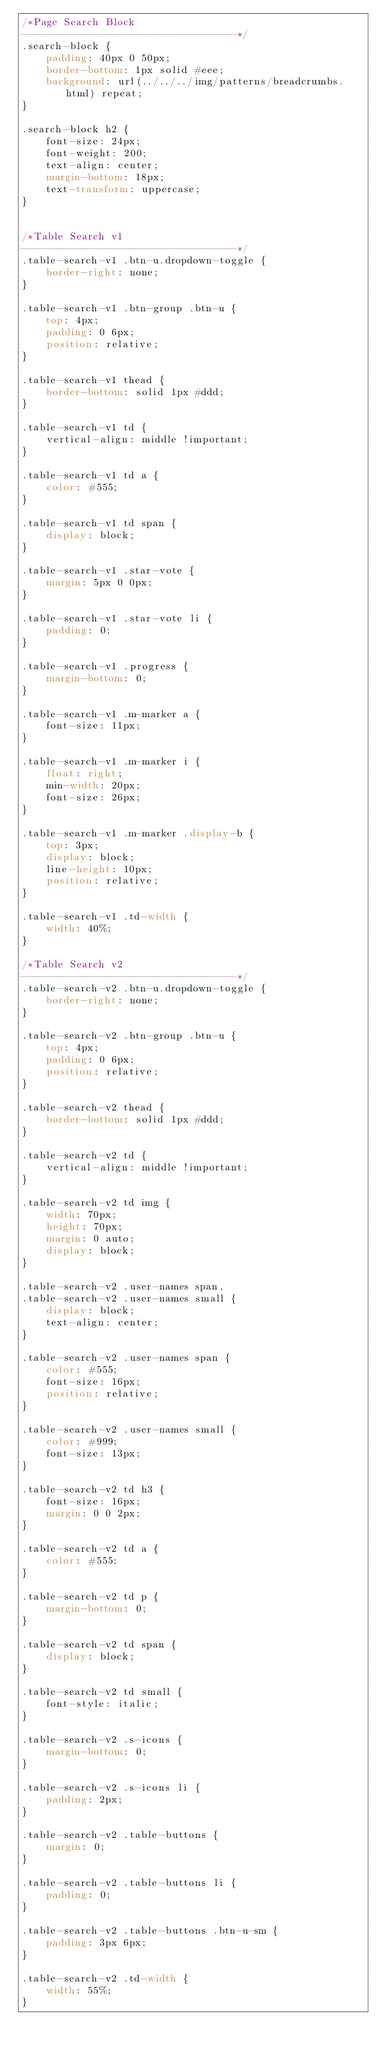<code> <loc_0><loc_0><loc_500><loc_500><_CSS_>/*Page Search Block
------------------------------------*/
.search-block {
	padding: 40px 0 50px;
	border-bottom: 1px solid #eee;
	background: url(../../../img/patterns/breadcrumbs.html) repeat;
}

.search-block h2 {
	font-size: 24px;
	font-weight: 200;
	text-align: center;
	margin-bottom: 18px;
	text-transform: uppercase;
}


/*Table Search v1
------------------------------------*/
.table-search-v1 .btn-u.dropdown-toggle {
	border-right: none;
}

.table-search-v1 .btn-group .btn-u {
	top: 4px;
	padding: 0 6px;
	position: relative;
}

.table-search-v1 thead {
	border-bottom: solid 1px #ddd;
}

.table-search-v1 td {
	vertical-align: middle !important;
}

.table-search-v1 td a {
	color: #555;
}

.table-search-v1 td span {
	display: block;
}

.table-search-v1 .star-vote {
	margin: 5px 0 0px;
}

.table-search-v1 .star-vote li {
	padding: 0;
}

.table-search-v1 .progress {
	margin-bottom: 0;
}

.table-search-v1 .m-marker a {
	font-size: 11px;
}

.table-search-v1 .m-marker i {
	float: right;
	min-width: 20px;
	font-size: 26px;
}

.table-search-v1 .m-marker .display-b {
	top: 3px;
	display: block;
	line-height: 10px;
	position: relative;
}

.table-search-v1 .td-width {
	width: 40%;
}

/*Table Search v2
------------------------------------*/
.table-search-v2 .btn-u.dropdown-toggle {
	border-right: none;
}

.table-search-v2 .btn-group .btn-u {
	top: 4px;
	padding: 0 6px;
	position: relative;
}

.table-search-v2 thead {
	border-bottom: solid 1px #ddd;
}

.table-search-v2 td {
	vertical-align: middle !important;
}

.table-search-v2 td img {
	width: 70px;
	height: 70px;
	margin: 0 auto;
	display: block;
}

.table-search-v2 .user-names span,
.table-search-v2 .user-names small {
	display: block;
	text-align: center;
}

.table-search-v2 .user-names span {
	color: #555;
	font-size: 16px;
	position: relative;
}

.table-search-v2 .user-names small {
	color: #999;
	font-size: 13px;
}

.table-search-v2 td h3 {
	font-size: 16px;
	margin: 0 0 2px;
}

.table-search-v2 td a {
	color: #555;
}

.table-search-v2 td p {
	margin-bottom: 0;
}

.table-search-v2 td span {
	display: block;
}

.table-search-v2 td small {
	font-style: italic;
}

.table-search-v2 .s-icons {
	margin-bottom: 0;
}

.table-search-v2 .s-icons li {
	padding: 2px;
}

.table-search-v2 .table-buttons {
	margin: 0;
}

.table-search-v2 .table-buttons li {
	padding: 0;
}

.table-search-v2 .table-buttons .btn-u-sm {
	padding: 3px 6px;
}

.table-search-v2 .td-width {
	width: 55%;
}</code> 